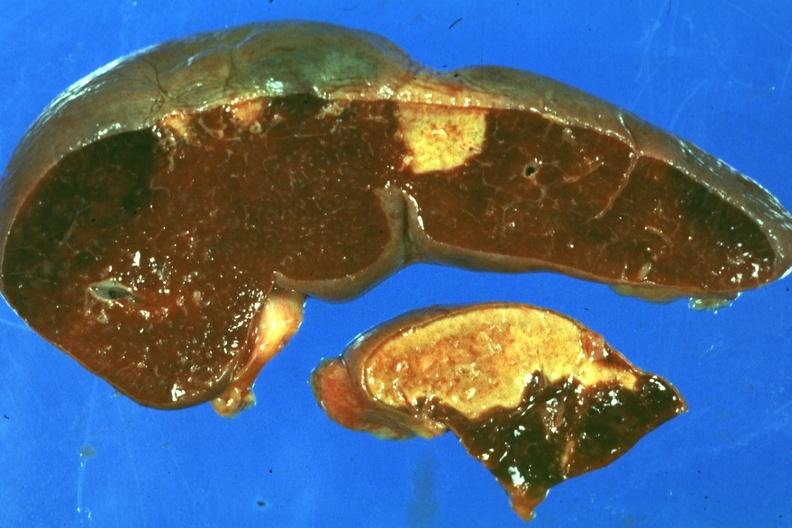s acute peritonitis present?
Answer the question using a single word or phrase. No 